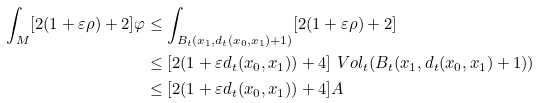Convert formula to latex. <formula><loc_0><loc_0><loc_500><loc_500>\int _ { M } [ 2 ( 1 + \varepsilon \rho ) + 2 ] \varphi & \leq \int _ { B _ { t } ( x _ { 1 } , d _ { t } ( x _ { 0 } , x _ { 1 } ) + 1 ) } [ 2 ( 1 + \varepsilon \rho ) + 2 ] \\ & \leq [ 2 ( 1 + \varepsilon d _ { t } ( x _ { 0 } , x _ { 1 } ) ) + 4 ] \ V o l _ { t } ( B _ { t } ( x _ { 1 } , d _ { t } ( x _ { 0 } , x _ { 1 } ) + 1 ) ) \\ & \leq [ 2 ( 1 + \varepsilon d _ { t } ( x _ { 0 } , x _ { 1 } ) ) + 4 ] A</formula> 